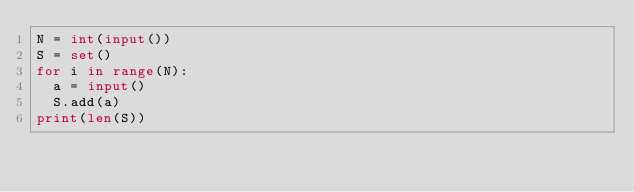Convert code to text. <code><loc_0><loc_0><loc_500><loc_500><_Python_>N = int(input())
S = set()
for i in range(N):
  a = input()
  S.add(a)
print(len(S))
    </code> 